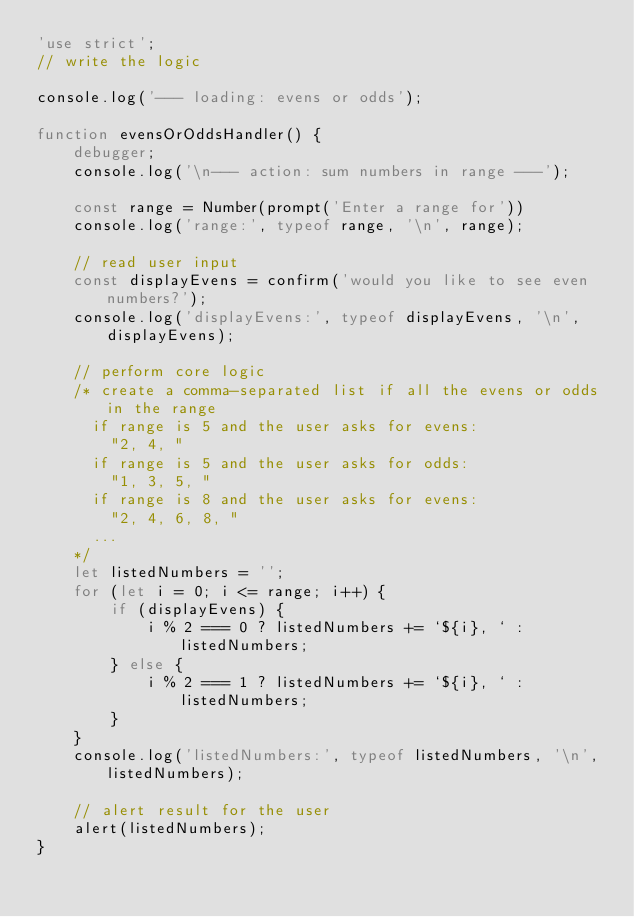Convert code to text. <code><loc_0><loc_0><loc_500><loc_500><_JavaScript_>'use strict';
// write the logic

console.log('--- loading: evens or odds');

function evensOrOddsHandler() {
    debugger;
    console.log('\n--- action: sum numbers in range ---');

    const range = Number(prompt('Enter a range for'))
    console.log('range:', typeof range, '\n', range);

    // read user input
    const displayEvens = confirm('would you like to see even numbers?');
    console.log('displayEvens:', typeof displayEvens, '\n', displayEvens);

    // perform core logic
    /* create a comma-separated list if all the evens or odds in the range
      if range is 5 and the user asks for evens:
        "2, 4, "
      if range is 5 and the user asks for odds:
        "1, 3, 5, "
      if range is 8 and the user asks for evens:
        "2, 4, 6, 8, "
      ...
    */
    let listedNumbers = '';
    for (let i = 0; i <= range; i++) {
        if (displayEvens) {
            i % 2 === 0 ? listedNumbers += `${i}, ` : listedNumbers;
        } else {
            i % 2 === 1 ? listedNumbers += `${i}, ` : listedNumbers;
        }
    }
    console.log('listedNumbers:', typeof listedNumbers, '\n', listedNumbers);

    // alert result for the user
    alert(listedNumbers);
}</code> 